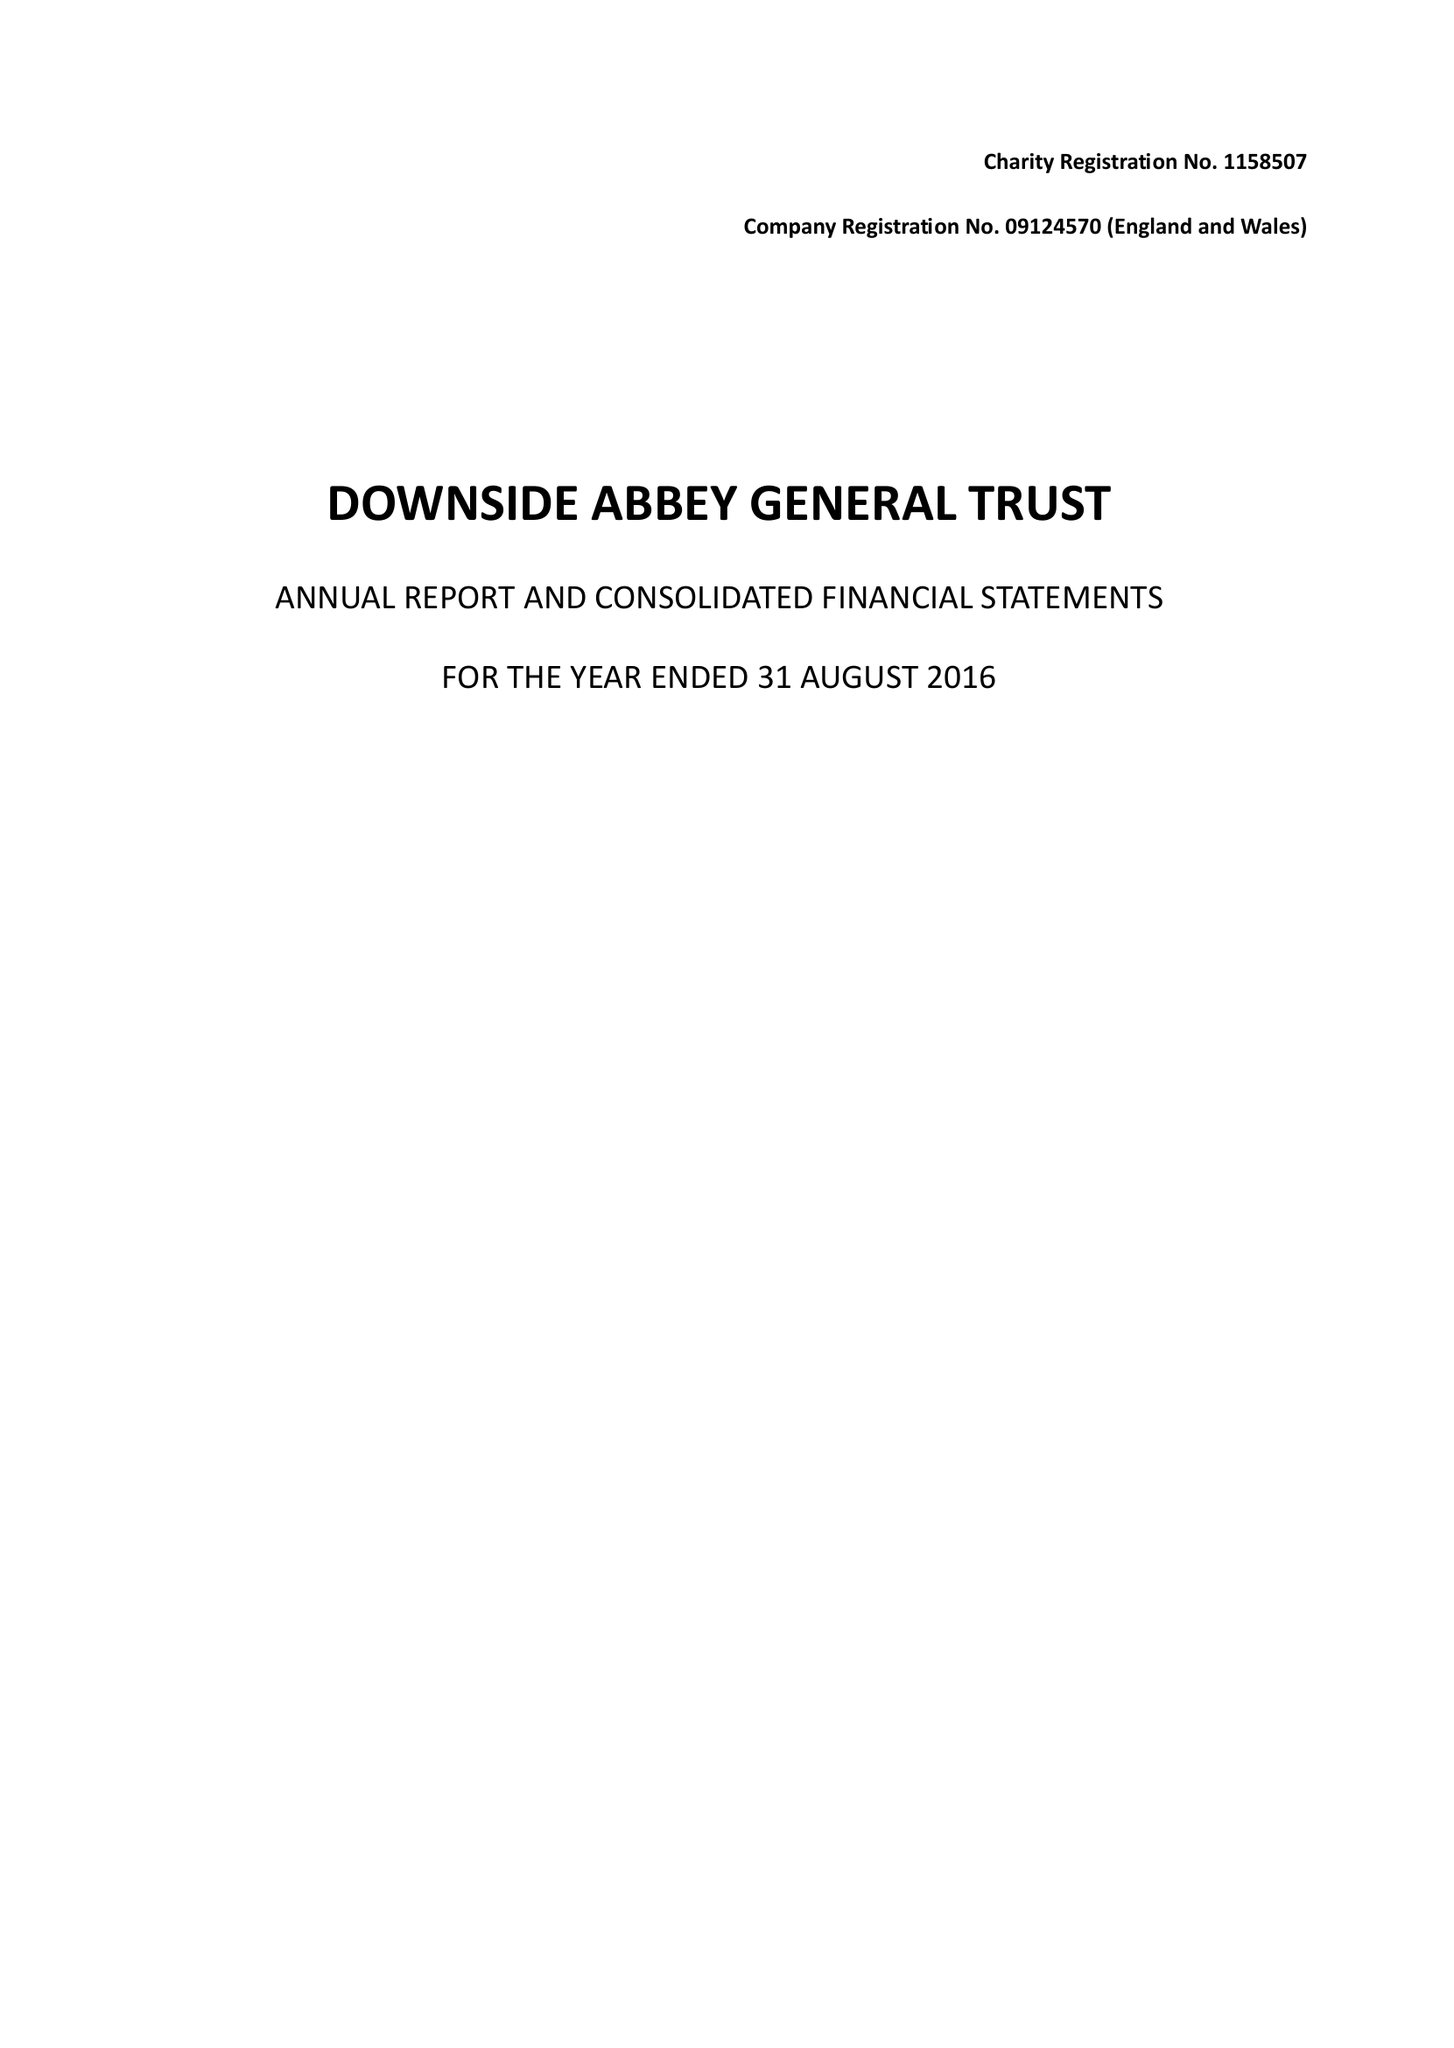What is the value for the income_annually_in_british_pounds?
Answer the question using a single word or phrase. 27515230.00 